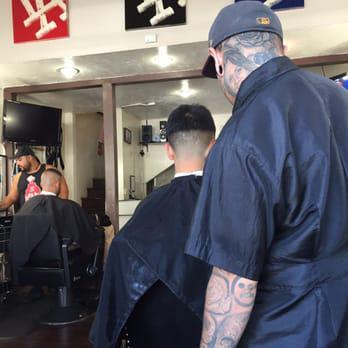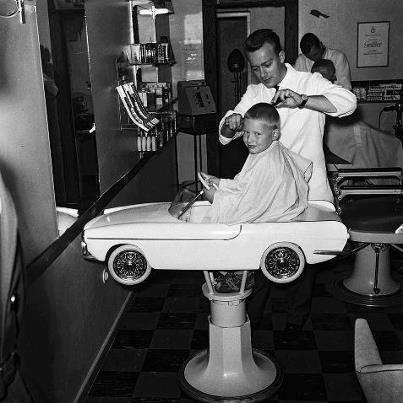The first image is the image on the left, the second image is the image on the right. Considering the images on both sides, is "A barbershop in one image has a row of at least four empty barber chairs, with bench seating at the wall behind." valid? Answer yes or no. No. 